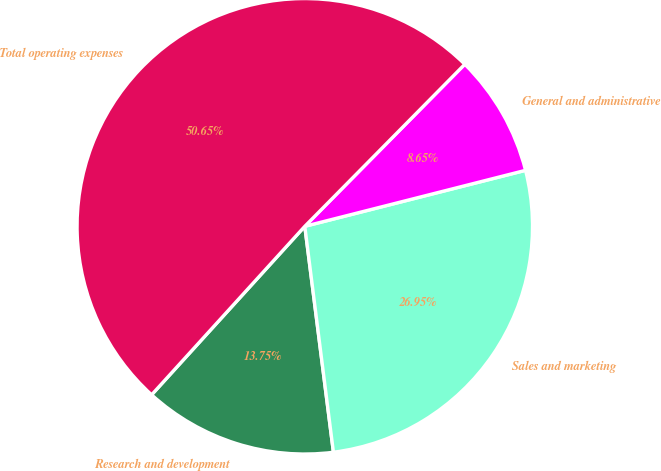<chart> <loc_0><loc_0><loc_500><loc_500><pie_chart><fcel>Research and development<fcel>Sales and marketing<fcel>General and administrative<fcel>Total operating expenses<nl><fcel>13.75%<fcel>26.95%<fcel>8.65%<fcel>50.66%<nl></chart> 